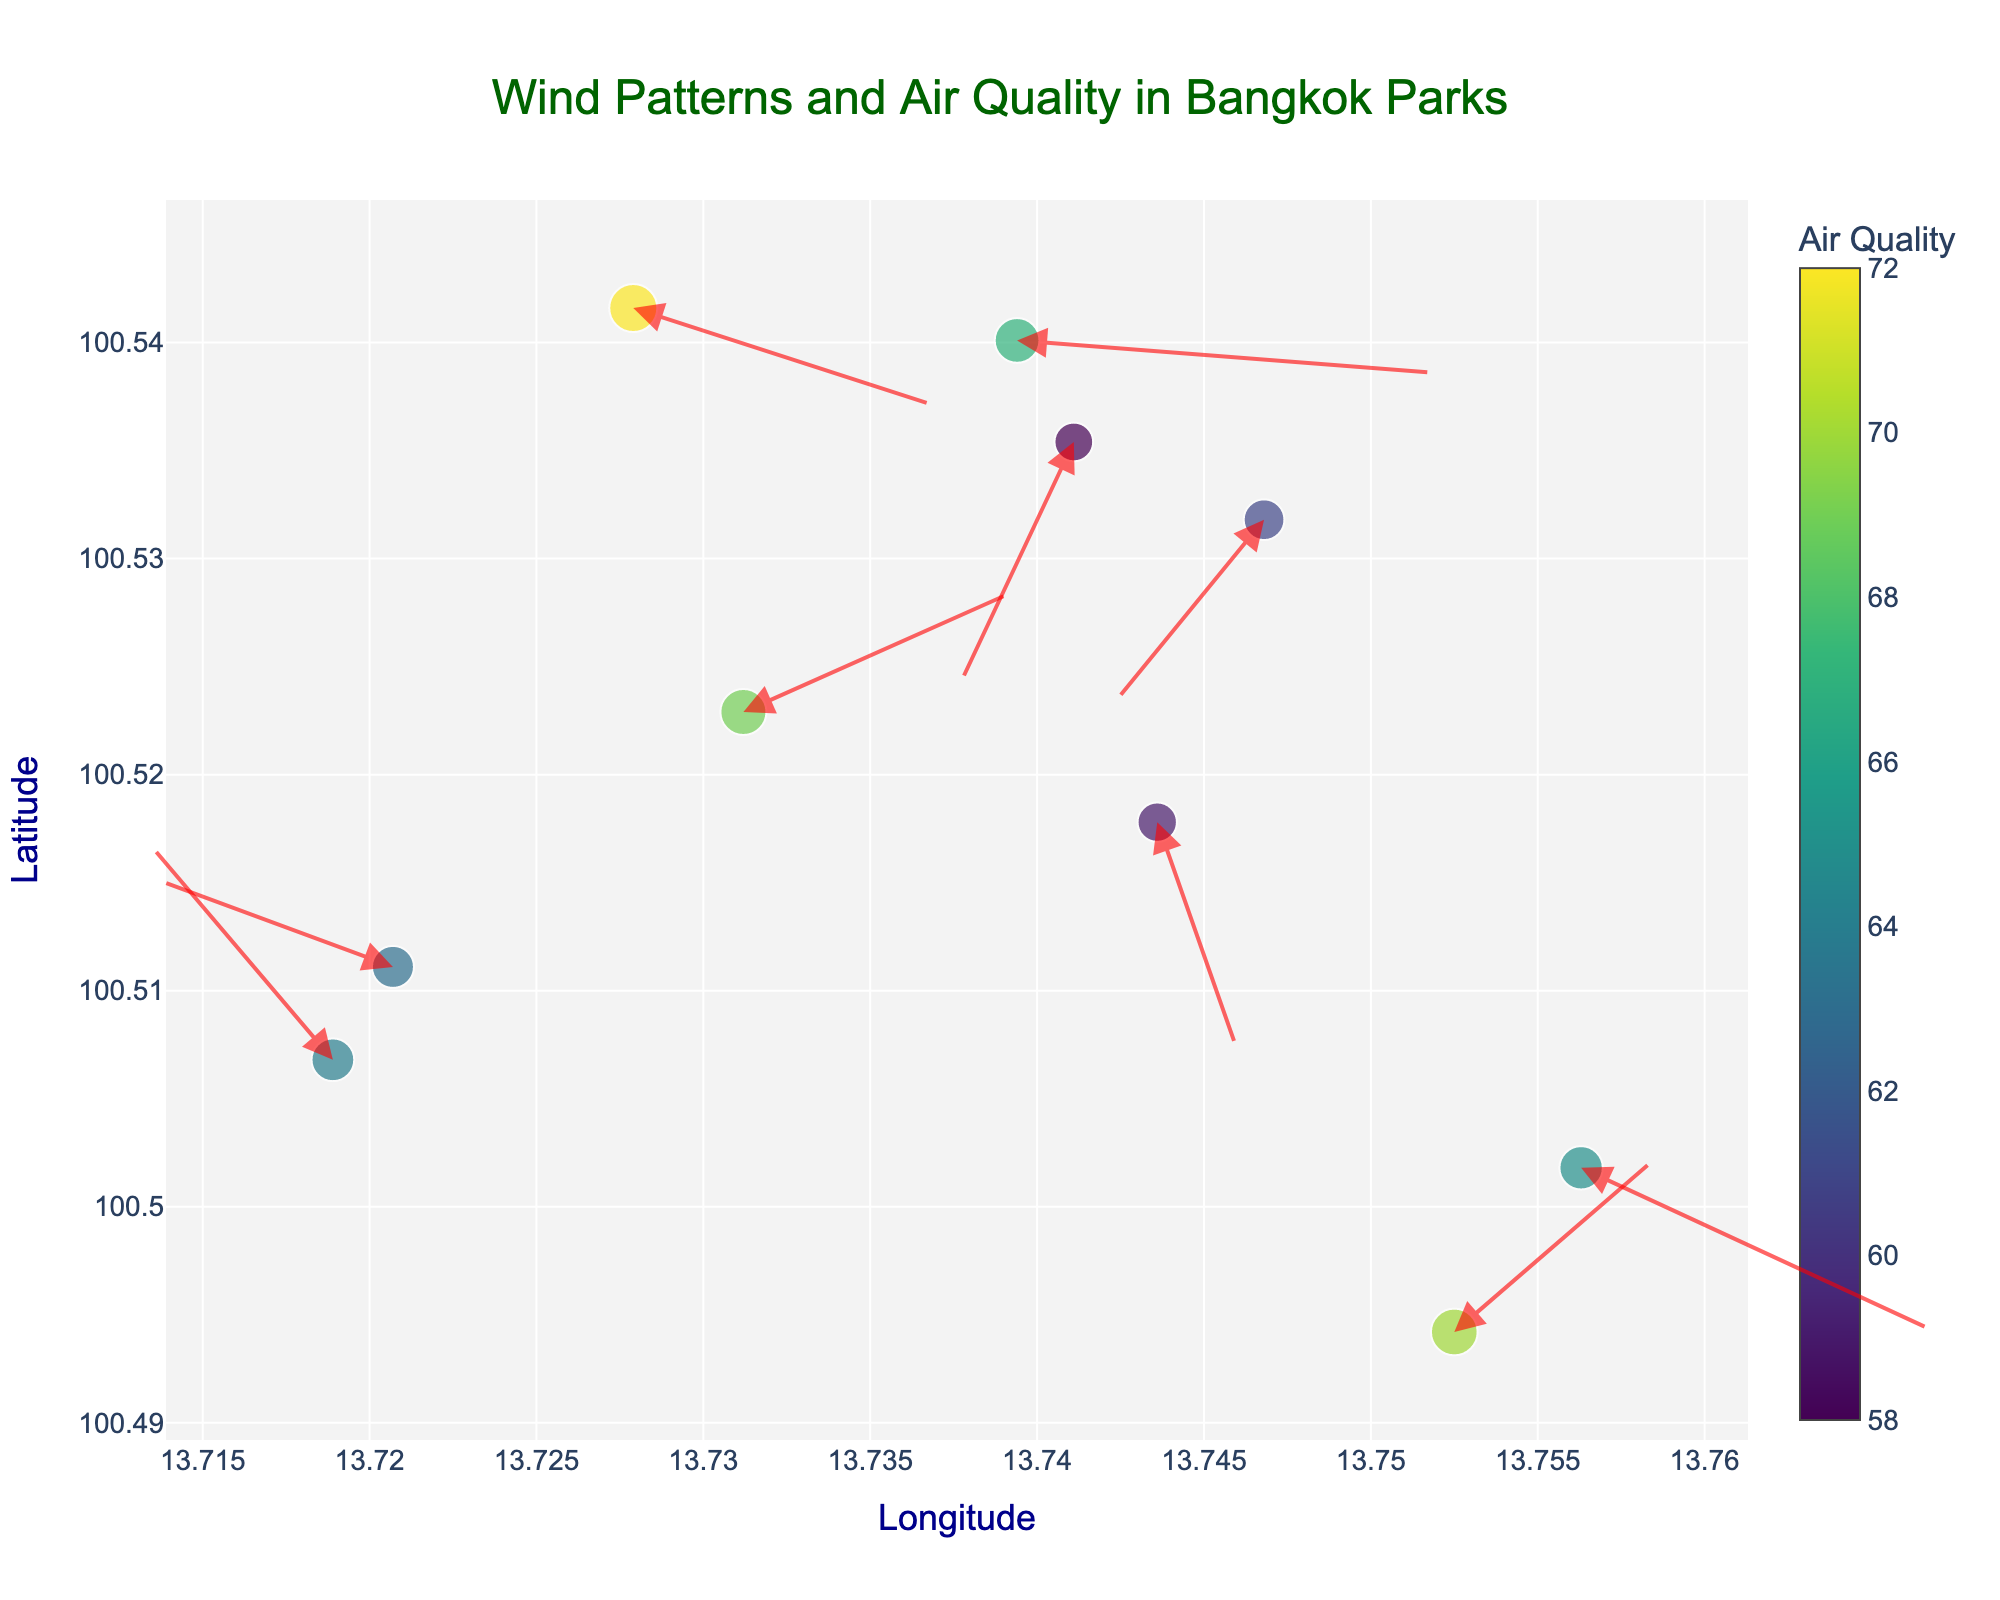What is the title of the plot? The title is centrally located at the top of the plot. It provides an overview of the visualized data.
Answer: Wind Patterns and Air Quality in Bangkok Parks What is represented by the size of the markers? The size of the markers is proportional to the air quality values at different locations. Larger markers indicate higher air quality values.
Answer: Air quality What is the color scale used for the markers? The color of the markers is based on the Viridis colorscale, with a color bar indicating air quality values.
Answer: Viridis Which park has the highest air quality? Find the marker with the largest size and check its air quality value. The park at coordinates (13.7279, 100.5416) has the highest air quality of 72.
Answer: 72 What is the direction of the wind at (13.7563, 100.5018)? Arrows indicate the direction and magnitude of the wind. For (13.7563, 100.5018), the arrow points towards the coordinates diminished by the u and v components, indicating a south-westward direction.
Answer: South-west At which park is the wind speed the highest? Calculate the wind speed from the u and v components for each park. The highest value corresponds to (13.7394, 100.5401), which has wind components u = 2.5 and v = -0.3. The wind speed is sqrt(2.5^2 + (-0.3)^2) ≈ 2.52.
Answer: (13.7394, 100.5401) What range do the air quality values fall within? Identify the minimum and maximum air quality values from the data. Here, the minimum is 58 and the maximum is 72.
Answer: 58 to 72 Which parks have wind vectors with both positive u and v components? Examine the u and v components; identify parks where both are positive. Parks with both components positive are (13.7525, 100.4942) and (13.7312, 100.5229).
Answer: (13.7525, 100.4942) and (13.7312, 100.5229) Which park has the lowest air quality, and what is its wind direction? Find the smallest air quality value. It's 58 for (13.7411, 100.5354), with wind direction indicated by u = -0.7 and v = -2.3, making the direction south-westward.
Answer: (13.7411, 100.5354), south-west Compare the wind speed of the park at (13.7525, 100.4942) to the wind speed of the park at (13.7394, 100.5401). Which is higher? Calculate the wind speed for both parks. (13.7525, 100.4942) has u = 1.2, v = 1.6, speed = sqrt(1.2^2 + 1.6^2) ≈ 2.0. (13.7394, 100.5401) has u=2.5, v=-0.3, speed = sqrt(2.5^2 + (-0.3)^2) ≈ 2.52. The latter is higher.
Answer: (13.7394, 100.5401) 